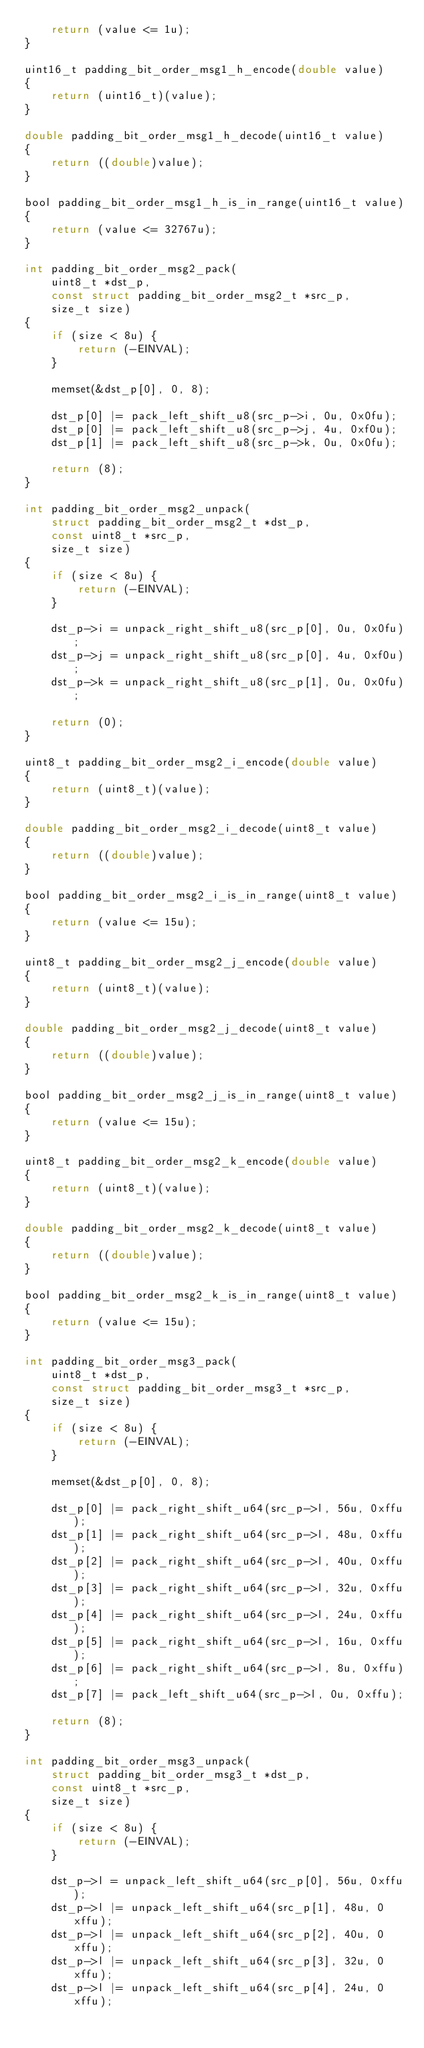<code> <loc_0><loc_0><loc_500><loc_500><_C_>    return (value <= 1u);
}

uint16_t padding_bit_order_msg1_h_encode(double value)
{
    return (uint16_t)(value);
}

double padding_bit_order_msg1_h_decode(uint16_t value)
{
    return ((double)value);
}

bool padding_bit_order_msg1_h_is_in_range(uint16_t value)
{
    return (value <= 32767u);
}

int padding_bit_order_msg2_pack(
    uint8_t *dst_p,
    const struct padding_bit_order_msg2_t *src_p,
    size_t size)
{
    if (size < 8u) {
        return (-EINVAL);
    }

    memset(&dst_p[0], 0, 8);

    dst_p[0] |= pack_left_shift_u8(src_p->i, 0u, 0x0fu);
    dst_p[0] |= pack_left_shift_u8(src_p->j, 4u, 0xf0u);
    dst_p[1] |= pack_left_shift_u8(src_p->k, 0u, 0x0fu);

    return (8);
}

int padding_bit_order_msg2_unpack(
    struct padding_bit_order_msg2_t *dst_p,
    const uint8_t *src_p,
    size_t size)
{
    if (size < 8u) {
        return (-EINVAL);
    }

    dst_p->i = unpack_right_shift_u8(src_p[0], 0u, 0x0fu);
    dst_p->j = unpack_right_shift_u8(src_p[0], 4u, 0xf0u);
    dst_p->k = unpack_right_shift_u8(src_p[1], 0u, 0x0fu);

    return (0);
}

uint8_t padding_bit_order_msg2_i_encode(double value)
{
    return (uint8_t)(value);
}

double padding_bit_order_msg2_i_decode(uint8_t value)
{
    return ((double)value);
}

bool padding_bit_order_msg2_i_is_in_range(uint8_t value)
{
    return (value <= 15u);
}

uint8_t padding_bit_order_msg2_j_encode(double value)
{
    return (uint8_t)(value);
}

double padding_bit_order_msg2_j_decode(uint8_t value)
{
    return ((double)value);
}

bool padding_bit_order_msg2_j_is_in_range(uint8_t value)
{
    return (value <= 15u);
}

uint8_t padding_bit_order_msg2_k_encode(double value)
{
    return (uint8_t)(value);
}

double padding_bit_order_msg2_k_decode(uint8_t value)
{
    return ((double)value);
}

bool padding_bit_order_msg2_k_is_in_range(uint8_t value)
{
    return (value <= 15u);
}

int padding_bit_order_msg3_pack(
    uint8_t *dst_p,
    const struct padding_bit_order_msg3_t *src_p,
    size_t size)
{
    if (size < 8u) {
        return (-EINVAL);
    }

    memset(&dst_p[0], 0, 8);

    dst_p[0] |= pack_right_shift_u64(src_p->l, 56u, 0xffu);
    dst_p[1] |= pack_right_shift_u64(src_p->l, 48u, 0xffu);
    dst_p[2] |= pack_right_shift_u64(src_p->l, 40u, 0xffu);
    dst_p[3] |= pack_right_shift_u64(src_p->l, 32u, 0xffu);
    dst_p[4] |= pack_right_shift_u64(src_p->l, 24u, 0xffu);
    dst_p[5] |= pack_right_shift_u64(src_p->l, 16u, 0xffu);
    dst_p[6] |= pack_right_shift_u64(src_p->l, 8u, 0xffu);
    dst_p[7] |= pack_left_shift_u64(src_p->l, 0u, 0xffu);

    return (8);
}

int padding_bit_order_msg3_unpack(
    struct padding_bit_order_msg3_t *dst_p,
    const uint8_t *src_p,
    size_t size)
{
    if (size < 8u) {
        return (-EINVAL);
    }

    dst_p->l = unpack_left_shift_u64(src_p[0], 56u, 0xffu);
    dst_p->l |= unpack_left_shift_u64(src_p[1], 48u, 0xffu);
    dst_p->l |= unpack_left_shift_u64(src_p[2], 40u, 0xffu);
    dst_p->l |= unpack_left_shift_u64(src_p[3], 32u, 0xffu);
    dst_p->l |= unpack_left_shift_u64(src_p[4], 24u, 0xffu);</code> 